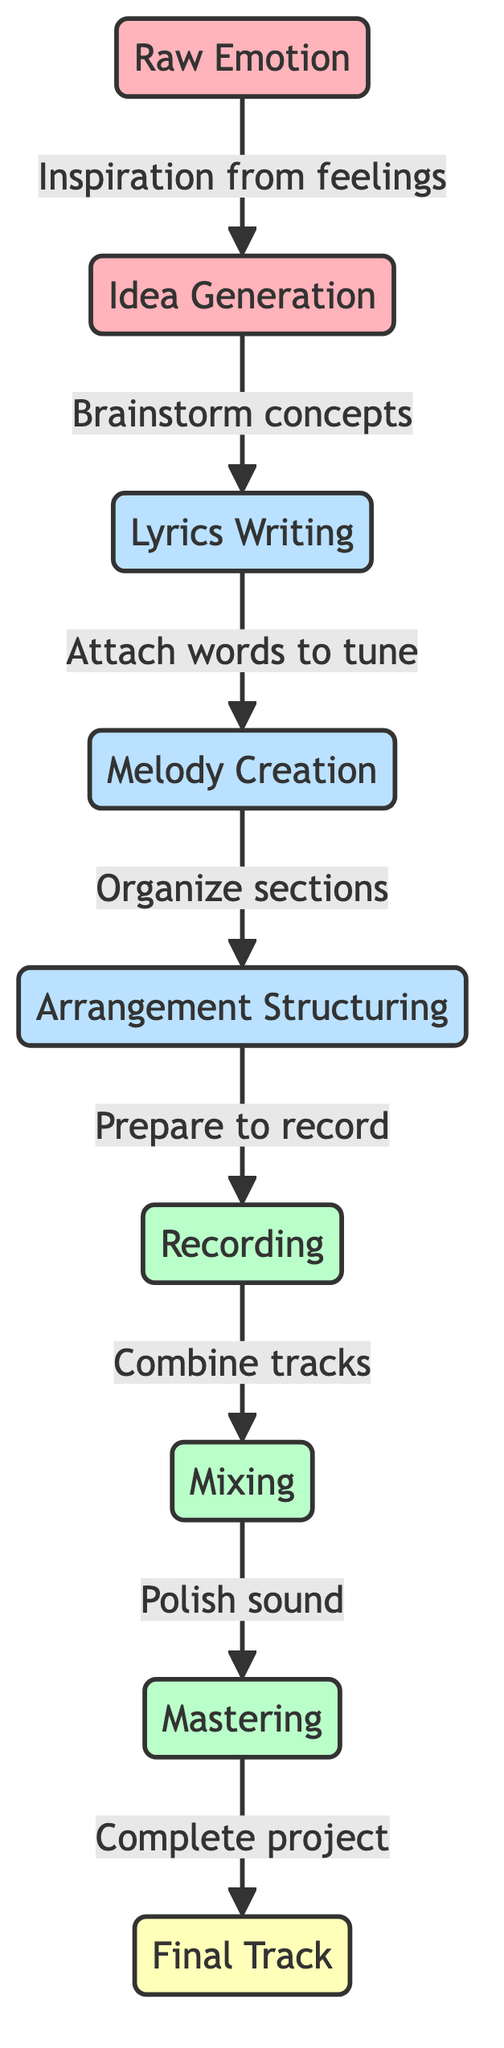What is the first phase of the songwriting process? The first phase in the diagram is labeled as "Raw Emotion." This is obtained by looking at the starting point of the flowchart which clearly shows that it begins with this phase.
Answer: Raw Emotion How many phases are there in total? By counting the nodes in the flowchart, we identify eight distinct phases, which include both the emotion and creation stages.
Answer: Eight What comes after 'Idea Generation'? Observing the flow from the node 'Idea Generation,' we see that the next phase is 'Lyrics Writing.' This is a direct follow-up as represented by the arrow.
Answer: Lyrics Writing Which phase involves polishing the sound? The diagram shows that 'Mixing' is the phase specifically related to polishing sound, as indicated by the terminology used in that section.
Answer: Mixing What is the purpose of 'Arrangement Structuring'? The purpose is clearly defined in the flowchart as it states "Organize sections," which outlines its role in the overall songwriting process.
Answer: Organize sections What is the relationship between 'Recording' and 'Mixing'? The relationship is sequential as 'Recording' leads directly to 'Mixing' according to the flow of the diagram, indicating that recording combines tracks before mixing occurs.
Answer: Sequential In which phase are words attached to the tune? The phase where words are attached to the tune is 'Lyrics Writing' according to the process established in the flowchart.
Answer: Lyrics Writing What comes before 'Mastering'? Following the flow, 'Mixing' is the phase that comes directly before 'Mastering,' indicating the steps taken toward completion of the track.
Answer: Mixing What color represents the production style phases? The color that symbolizes production style phases is a light green shade, as shown in the diagram which distinctly identifies production-related elements.
Answer: Light green 